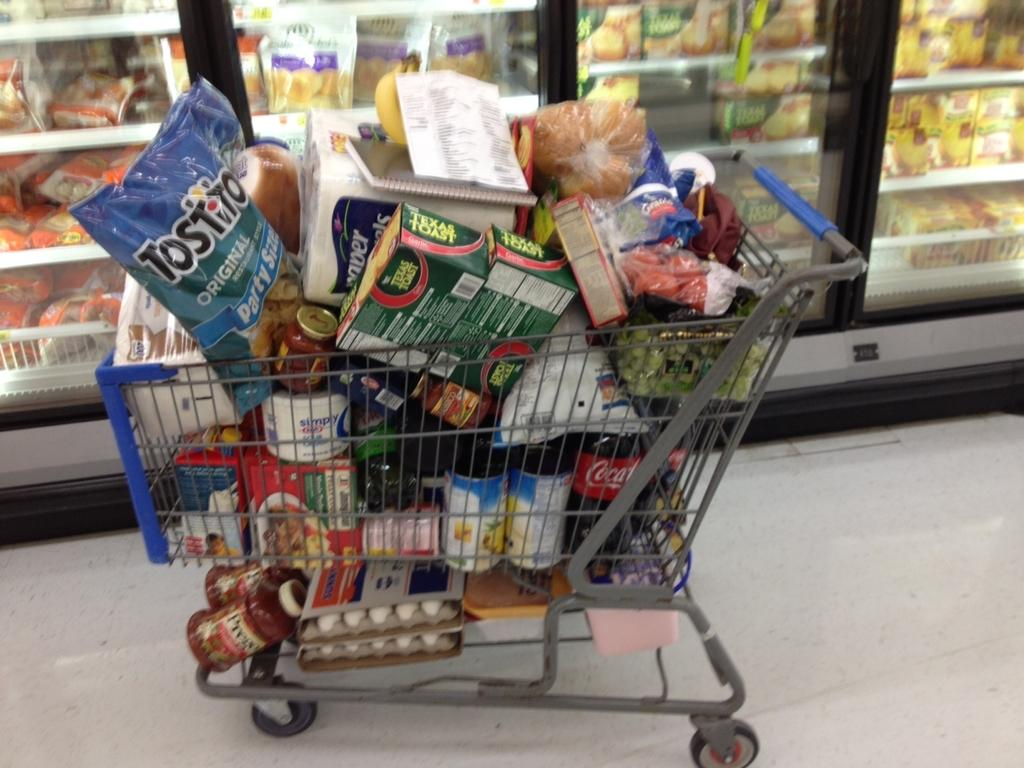<image>
Give a short and clear explanation of the subsequent image. A grocery cart is full of products, including Tostitos and Texas Toast. 